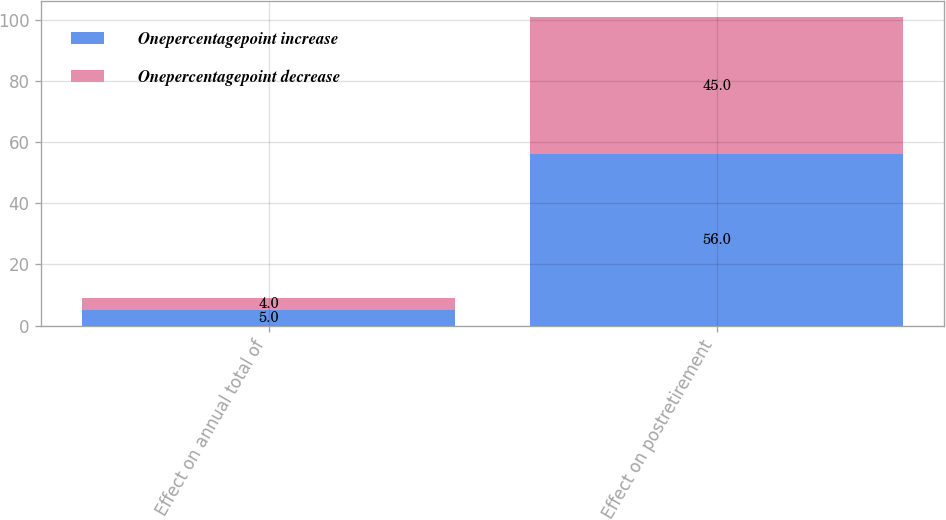<chart> <loc_0><loc_0><loc_500><loc_500><stacked_bar_chart><ecel><fcel>Effect on annual total of<fcel>Effect on postretirement<nl><fcel>Onepercentagepoint increase<fcel>5<fcel>56<nl><fcel>Onepercentagepoint decrease<fcel>4<fcel>45<nl></chart> 